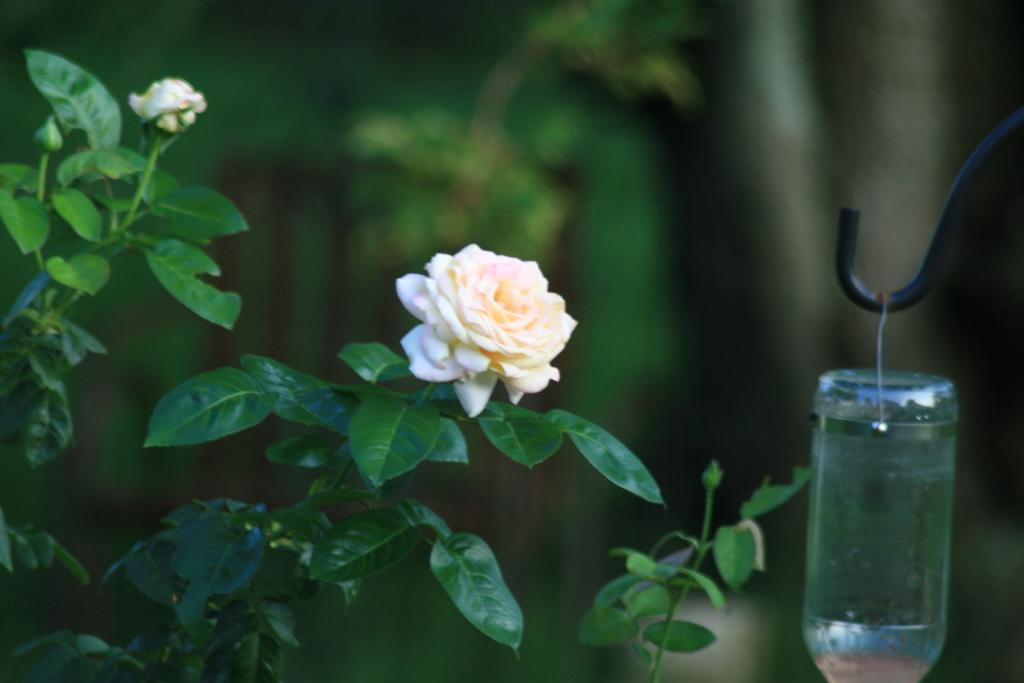What type of plant is on the left side of the image? There is a rose tree on the left side of the image. What can be seen on the rose tree? There is a rose and a rose bud on the tree. What is hanging on a rod on the right side of the image? There is a bottle hanging on a rod on the right side of the image. What rule is being enforced by the rose tree in the image? There is no rule being enforced by the rose tree in the image; it is simply a plant with flowers and buds. What force is being applied to the bottle hanging on the rod? There is no force being applied to the bottle hanging on the rod in the image; it is stationary. 